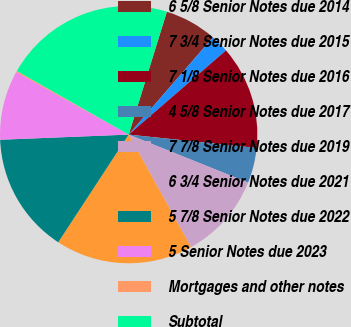Convert chart to OTSL. <chart><loc_0><loc_0><loc_500><loc_500><pie_chart><fcel>6 5/8 Senior Notes due 2014<fcel>7 3/4 Senior Notes due 2015<fcel>7 1/8 Senior Notes due 2016<fcel>4 5/8 Senior Notes due 2017<fcel>7 7/8 Senior Notes due 2019<fcel>6 3/4 Senior Notes due 2021<fcel>5 7/8 Senior Notes due 2022<fcel>5 Senior Notes due 2023<fcel>Mortgages and other notes<fcel>Subtotal<nl><fcel>6.57%<fcel>2.29%<fcel>13.0%<fcel>4.43%<fcel>10.86%<fcel>17.28%<fcel>15.14%<fcel>8.72%<fcel>0.15%<fcel>21.56%<nl></chart> 